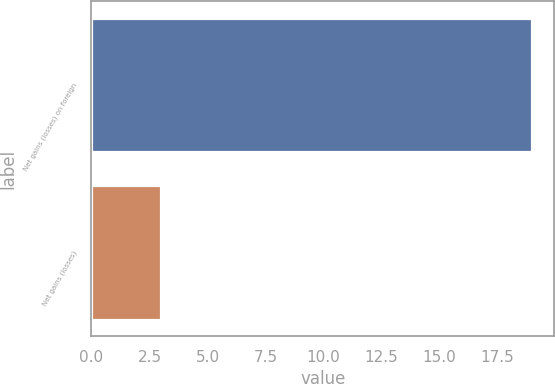Convert chart. <chart><loc_0><loc_0><loc_500><loc_500><bar_chart><fcel>Net gains (losses) on foreign<fcel>Net gains (losses)<nl><fcel>19<fcel>3<nl></chart> 